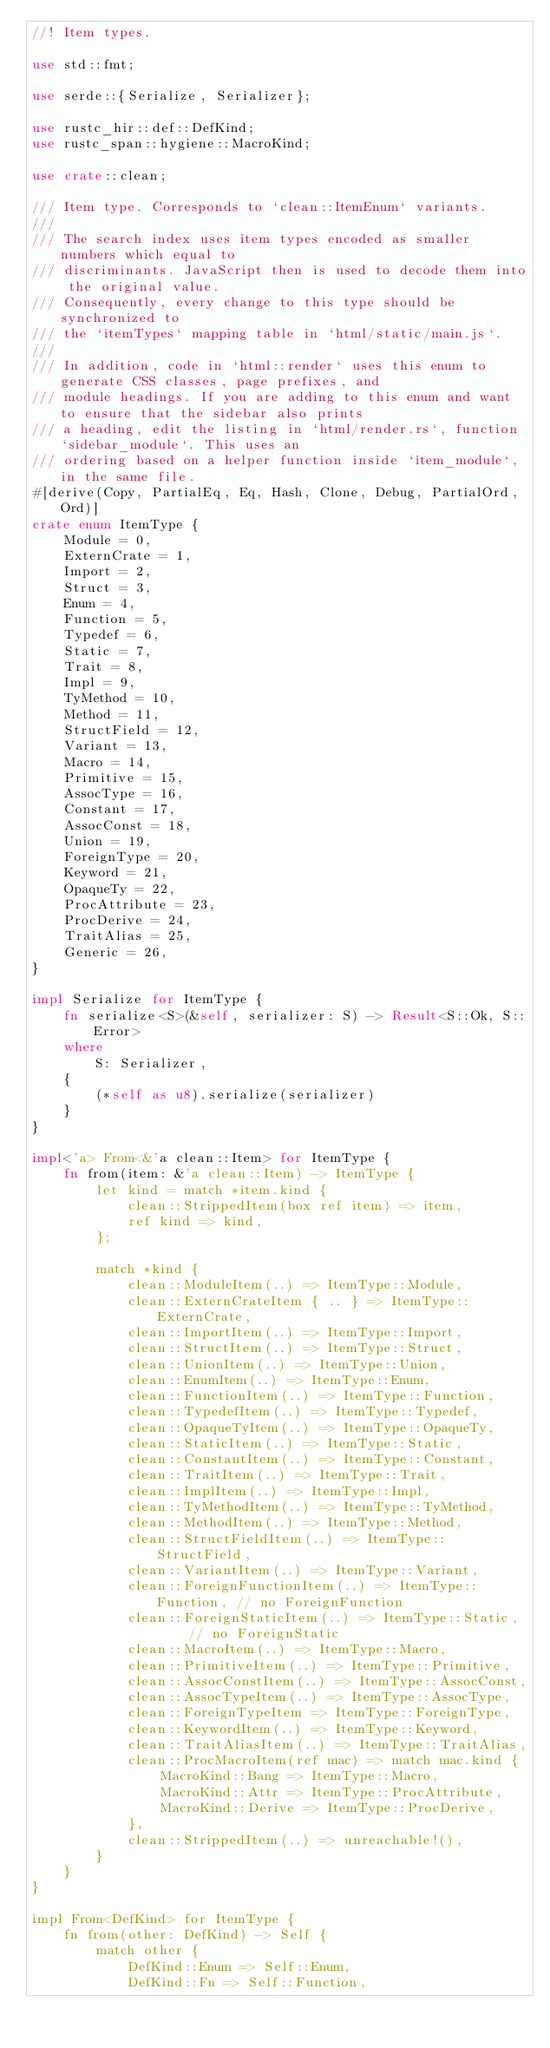<code> <loc_0><loc_0><loc_500><loc_500><_Rust_>//! Item types.

use std::fmt;

use serde::{Serialize, Serializer};

use rustc_hir::def::DefKind;
use rustc_span::hygiene::MacroKind;

use crate::clean;

/// Item type. Corresponds to `clean::ItemEnum` variants.
///
/// The search index uses item types encoded as smaller numbers which equal to
/// discriminants. JavaScript then is used to decode them into the original value.
/// Consequently, every change to this type should be synchronized to
/// the `itemTypes` mapping table in `html/static/main.js`.
///
/// In addition, code in `html::render` uses this enum to generate CSS classes, page prefixes, and
/// module headings. If you are adding to this enum and want to ensure that the sidebar also prints
/// a heading, edit the listing in `html/render.rs`, function `sidebar_module`. This uses an
/// ordering based on a helper function inside `item_module`, in the same file.
#[derive(Copy, PartialEq, Eq, Hash, Clone, Debug, PartialOrd, Ord)]
crate enum ItemType {
    Module = 0,
    ExternCrate = 1,
    Import = 2,
    Struct = 3,
    Enum = 4,
    Function = 5,
    Typedef = 6,
    Static = 7,
    Trait = 8,
    Impl = 9,
    TyMethod = 10,
    Method = 11,
    StructField = 12,
    Variant = 13,
    Macro = 14,
    Primitive = 15,
    AssocType = 16,
    Constant = 17,
    AssocConst = 18,
    Union = 19,
    ForeignType = 20,
    Keyword = 21,
    OpaqueTy = 22,
    ProcAttribute = 23,
    ProcDerive = 24,
    TraitAlias = 25,
    Generic = 26,
}

impl Serialize for ItemType {
    fn serialize<S>(&self, serializer: S) -> Result<S::Ok, S::Error>
    where
        S: Serializer,
    {
        (*self as u8).serialize(serializer)
    }
}

impl<'a> From<&'a clean::Item> for ItemType {
    fn from(item: &'a clean::Item) -> ItemType {
        let kind = match *item.kind {
            clean::StrippedItem(box ref item) => item,
            ref kind => kind,
        };

        match *kind {
            clean::ModuleItem(..) => ItemType::Module,
            clean::ExternCrateItem { .. } => ItemType::ExternCrate,
            clean::ImportItem(..) => ItemType::Import,
            clean::StructItem(..) => ItemType::Struct,
            clean::UnionItem(..) => ItemType::Union,
            clean::EnumItem(..) => ItemType::Enum,
            clean::FunctionItem(..) => ItemType::Function,
            clean::TypedefItem(..) => ItemType::Typedef,
            clean::OpaqueTyItem(..) => ItemType::OpaqueTy,
            clean::StaticItem(..) => ItemType::Static,
            clean::ConstantItem(..) => ItemType::Constant,
            clean::TraitItem(..) => ItemType::Trait,
            clean::ImplItem(..) => ItemType::Impl,
            clean::TyMethodItem(..) => ItemType::TyMethod,
            clean::MethodItem(..) => ItemType::Method,
            clean::StructFieldItem(..) => ItemType::StructField,
            clean::VariantItem(..) => ItemType::Variant,
            clean::ForeignFunctionItem(..) => ItemType::Function, // no ForeignFunction
            clean::ForeignStaticItem(..) => ItemType::Static,     // no ForeignStatic
            clean::MacroItem(..) => ItemType::Macro,
            clean::PrimitiveItem(..) => ItemType::Primitive,
            clean::AssocConstItem(..) => ItemType::AssocConst,
            clean::AssocTypeItem(..) => ItemType::AssocType,
            clean::ForeignTypeItem => ItemType::ForeignType,
            clean::KeywordItem(..) => ItemType::Keyword,
            clean::TraitAliasItem(..) => ItemType::TraitAlias,
            clean::ProcMacroItem(ref mac) => match mac.kind {
                MacroKind::Bang => ItemType::Macro,
                MacroKind::Attr => ItemType::ProcAttribute,
                MacroKind::Derive => ItemType::ProcDerive,
            },
            clean::StrippedItem(..) => unreachable!(),
        }
    }
}

impl From<DefKind> for ItemType {
    fn from(other: DefKind) -> Self {
        match other {
            DefKind::Enum => Self::Enum,
            DefKind::Fn => Self::Function,</code> 